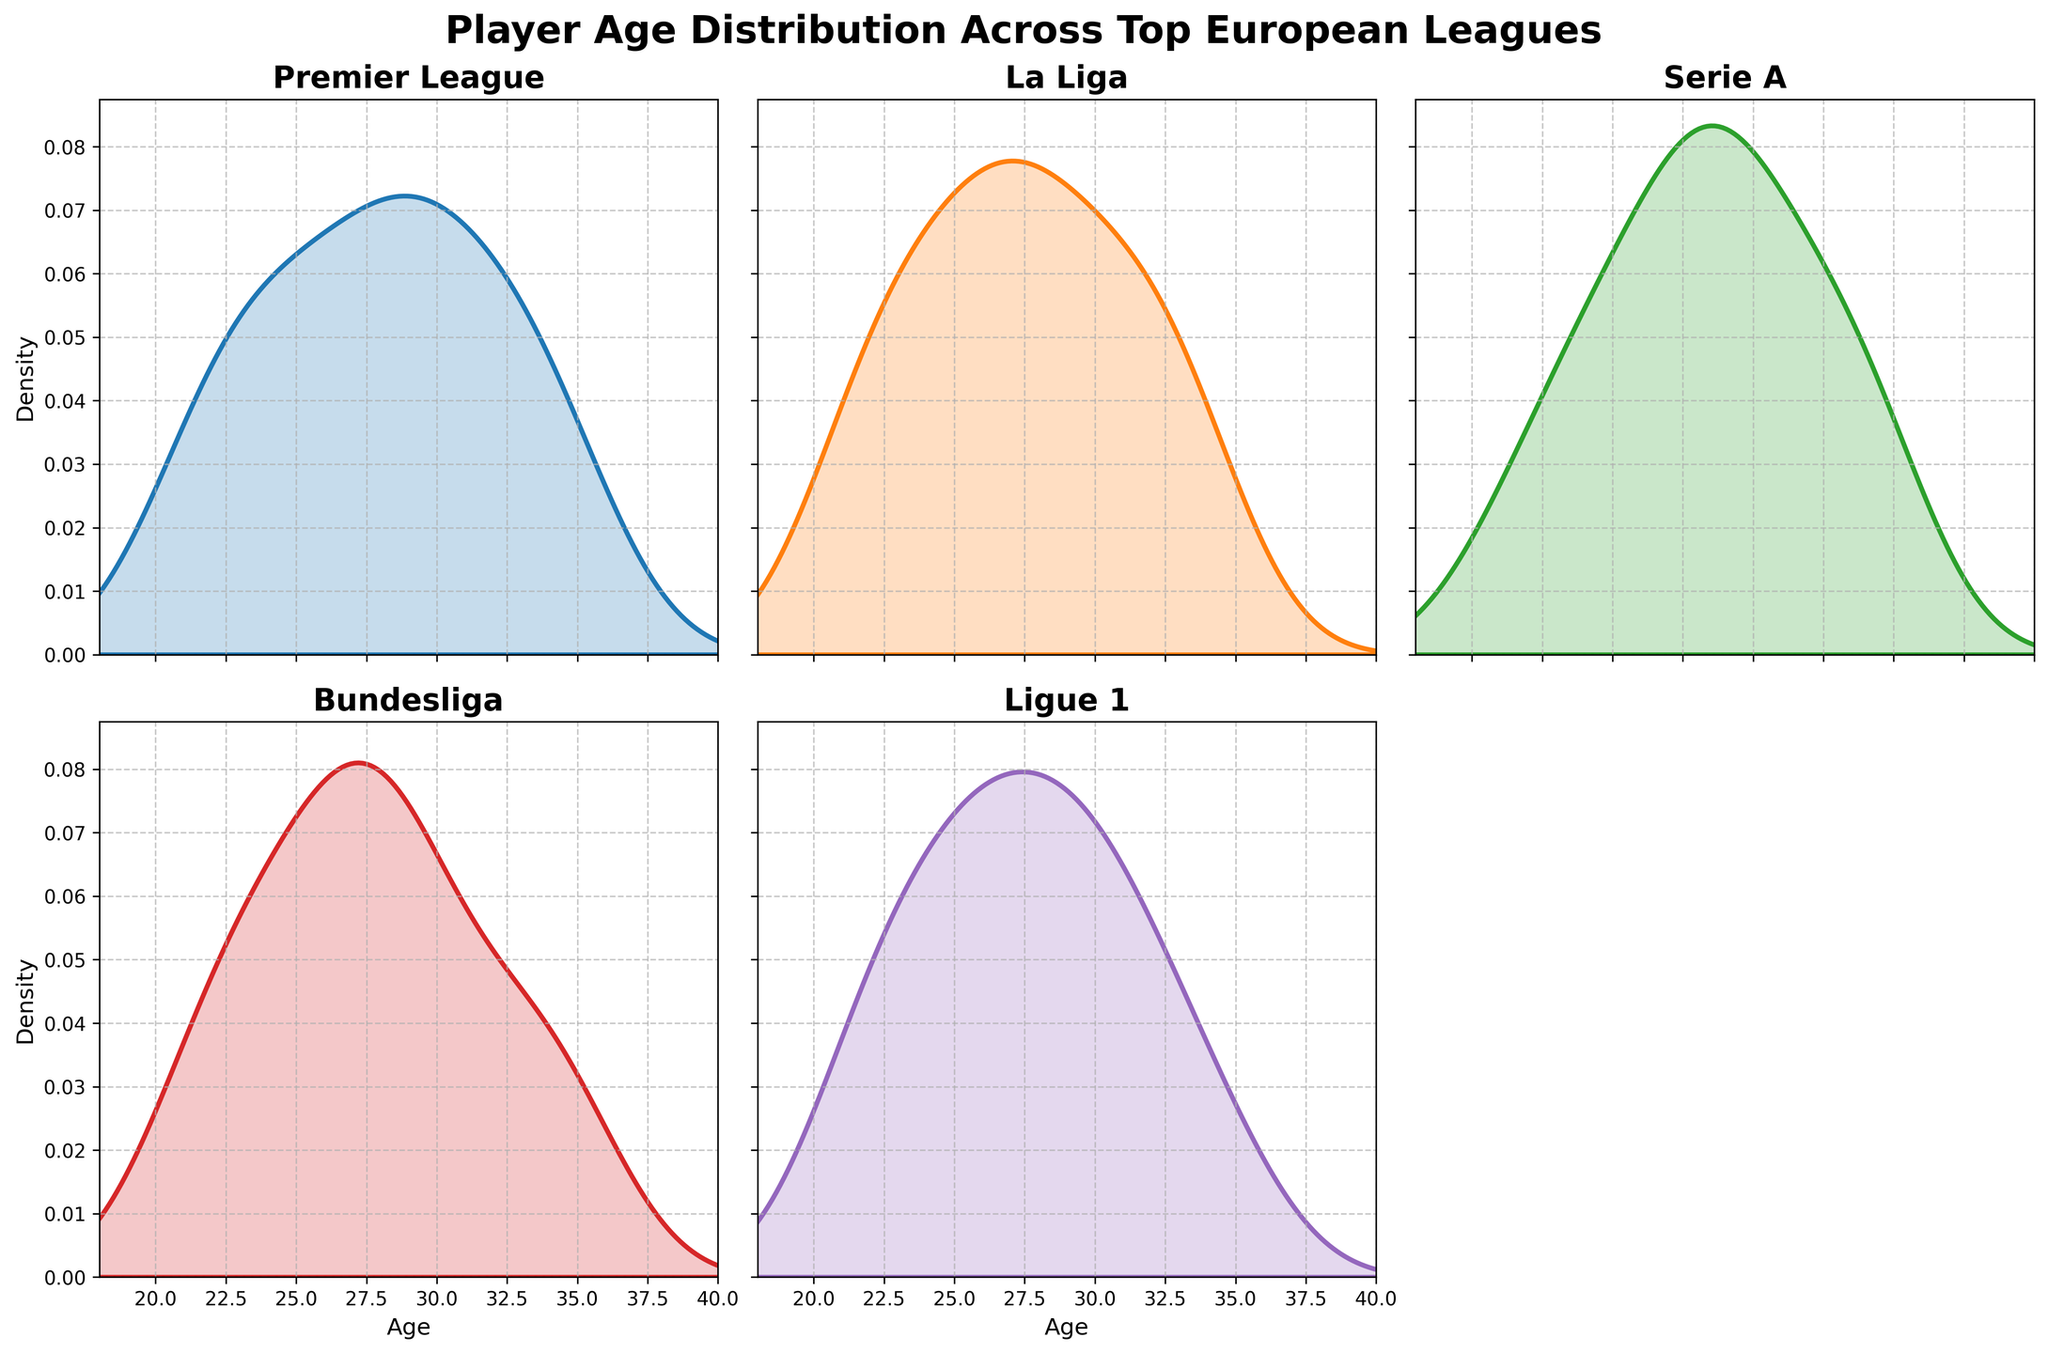What is the title of the figure? The title is usually displayed at the top of the figure. In this case, it is written in bold font, clearly stating the main subject of the plot.
Answer: Player Age Distribution Across Top European Leagues Which league's player age distribution is shown in the top left subplot? The top left subplot shows the title of the league in bold font. By examining the subplot at the first position, we see the name of the league.
Answer: Premier League How many subplots are there in total, and why is one of them empty? There are six positions for subplots, but only five are occupied because there are only five leagues analyzed. The figure has a 2x3 grid, leaving the sixth position empty.
Answer: 5 subplots, 1 is empty Which subplot shows the highest peak in the player age density? By comparing the peaks of each subplot, the one with the highest density at its peak represents the highest concentration of players within a specific age range.
Answer: Bundesliga Which leagues show a similar peak density in player ages? To answer this, compare the peaks across different subplots and identify which ones have similar shapes and heights.
Answer: Premier League and La Liga What is the general age range displayed on the x-axis across all subplots? Look at the x-axis labels across all subplots to determine the minimum and maximum player ages displayed.
Answer: 18 to 40 Between Premier League and Serie A, which league shows a wider spread of player ages? Comparing the density plots, identify where the distributions extend further along the x-axis, indicating a wider spread.
Answer: Serie A What does the area under the density curve represent for each league? The area under the density curve represents the total probability, which corresponds to the distribution of player ages in each league.
Answer: Player age distribution probability In which league do player ages seem to cluster around the late 20s? By examining the peaks of the density plots, determine which league has the highest concentration of players in their late 20s.
Answer: Ligue 1 